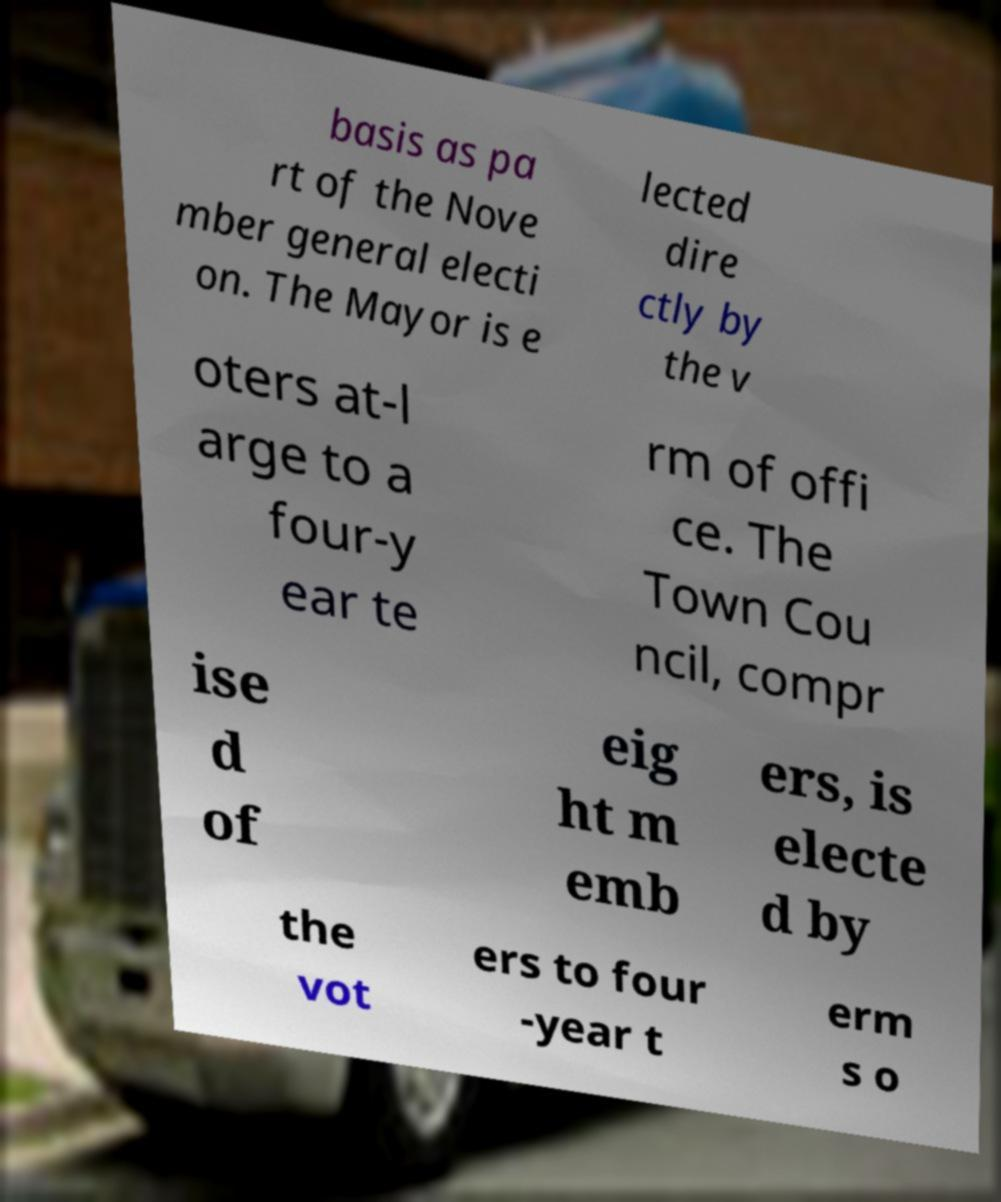Can you read and provide the text displayed in the image?This photo seems to have some interesting text. Can you extract and type it out for me? basis as pa rt of the Nove mber general electi on. The Mayor is e lected dire ctly by the v oters at-l arge to a four-y ear te rm of offi ce. The Town Cou ncil, compr ise d of eig ht m emb ers, is electe d by the vot ers to four -year t erm s o 